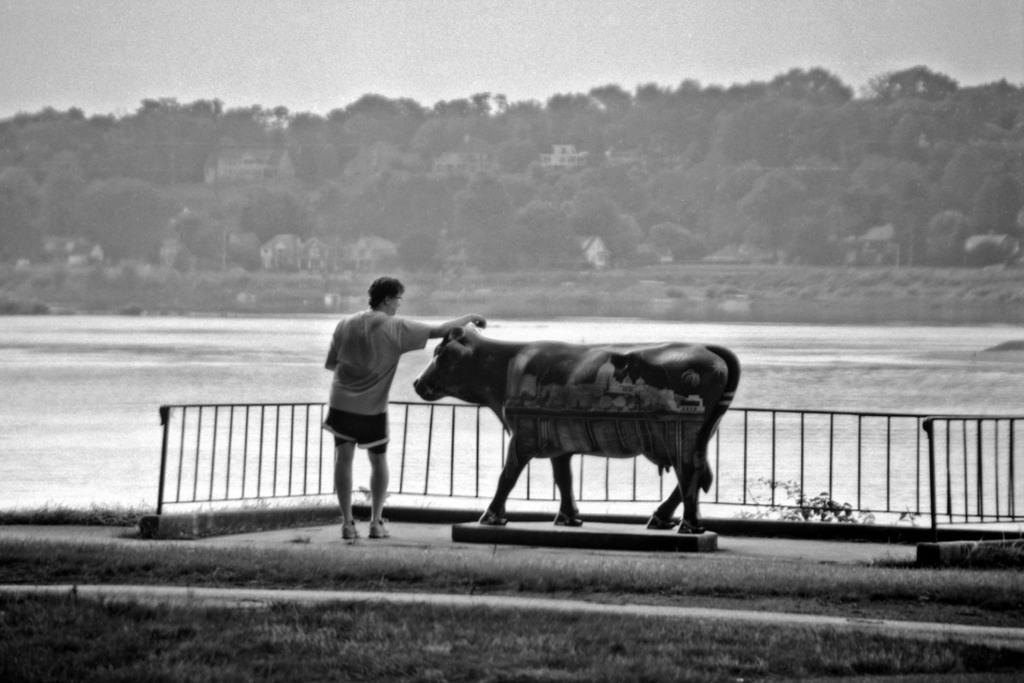What is the main subject in the image? There is a person standing in the image. What other living creature can be seen in the image? There is an animal in the image. What type of terrain is visible in the image? Grass is present in the image. What type of barrier is in the image? There is a fence in the image. What natural element is visible in the image? Water is visible in the image. What can be seen in the background of the image? There are trees, houses, and the sky visible in the background of the image. Where are the flowers arranged in the image? There are no flowers present in the image. What type of crate is being used to store the sheet in the image? There is no sheet or crate present in the image. 